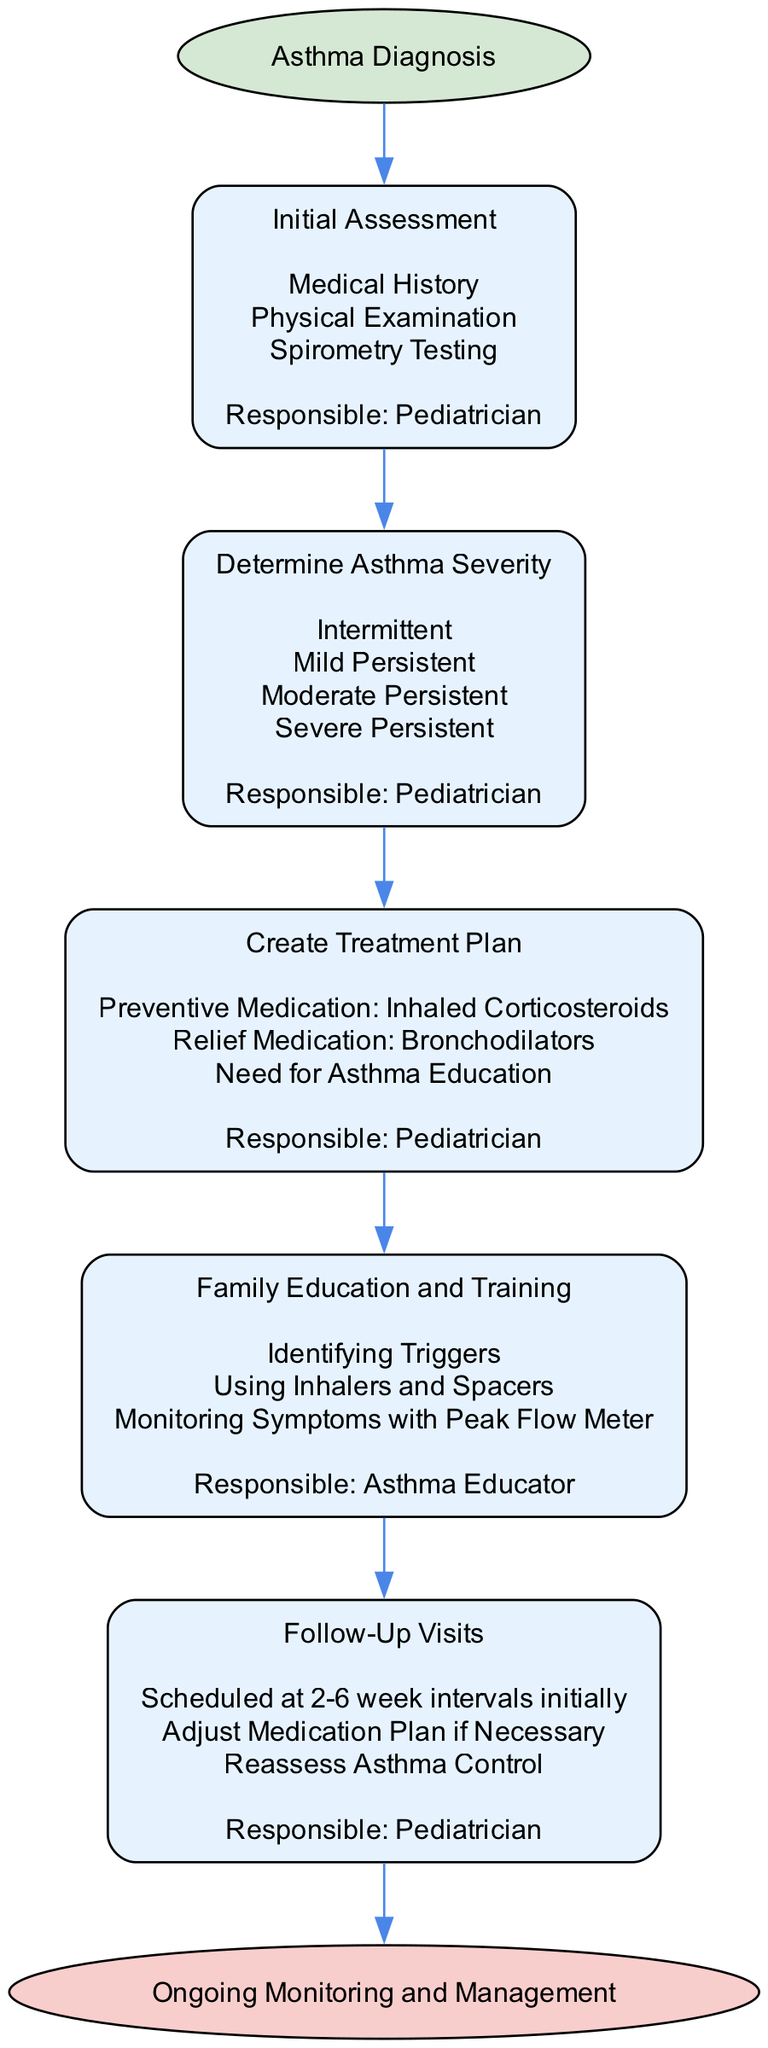What is the first step in the pathway? The diagram indicates the starting point of the treatment pathway is "Asthma Diagnosis," which is clearly labeled as the first step.
Answer: Asthma Diagnosis How many steps are there in the pathway? By counting each step outlined in the pathway, we see there are five distinct steps listed.
Answer: 5 Who is responsible for the "Family Education and Training" step? The diagram specifies that an "Asthma Educator" is the responsible party for this particular step in the treatment pathway.
Answer: Asthma Educator What types of assessments are included in the "Initial Assessment"? Under the "Initial Assessment" step, the details include "Medical History," "Physical Examination," and "Spirometry Testing," all of which are listed.
Answer: Medical History, Physical Examination, Spirometry Testing What is the last step mentioned in the clinical pathway? The final node in the diagram is labeled "Ongoing Monitoring and Management," marking the conclusion of the treatment pathway.
Answer: Ongoing Monitoring and Management Which responsible party determines asthma severity? The "Pediatrician" is designated as the responsible party for determining asthma severity according to the information in the pathway.
Answer: Pediatrician What medication is included in the treatment plan for asthma? The treatment plan specifies the use of "Inhaled Corticosteroids" as preventive medication included in the treatment approach.
Answer: Inhaled Corticosteroids What is the purpose of follow-up visits in the pathway? Follow-up visits serve multiple purposes, including adjusting the medication plan if necessary and reassessing asthma control, as indicated in the diagram.
Answer: Adjust Medication Plan, Reassess Asthma Control How are follow-up visits scheduled initially? The pathway states that follow-up visits are scheduled at "2-6 week intervals initially," outlining the frequency expected at the start of treatment.
Answer: 2-6 week intervals initially 